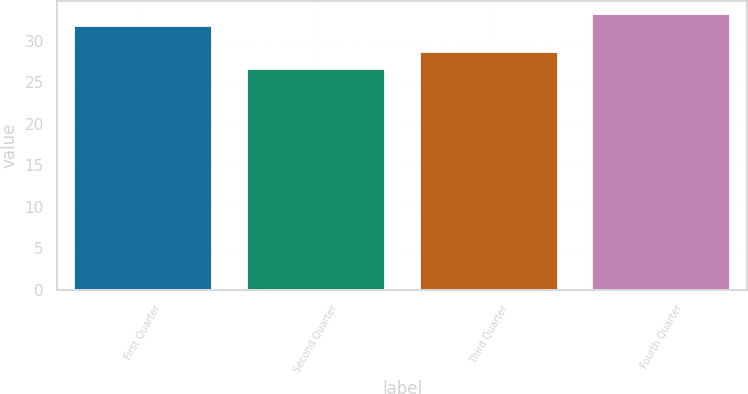Convert chart to OTSL. <chart><loc_0><loc_0><loc_500><loc_500><bar_chart><fcel>First Quarter<fcel>Second Quarter<fcel>Third Quarter<fcel>Fourth Quarter<nl><fcel>31.76<fcel>26.55<fcel>28.64<fcel>33.19<nl></chart> 